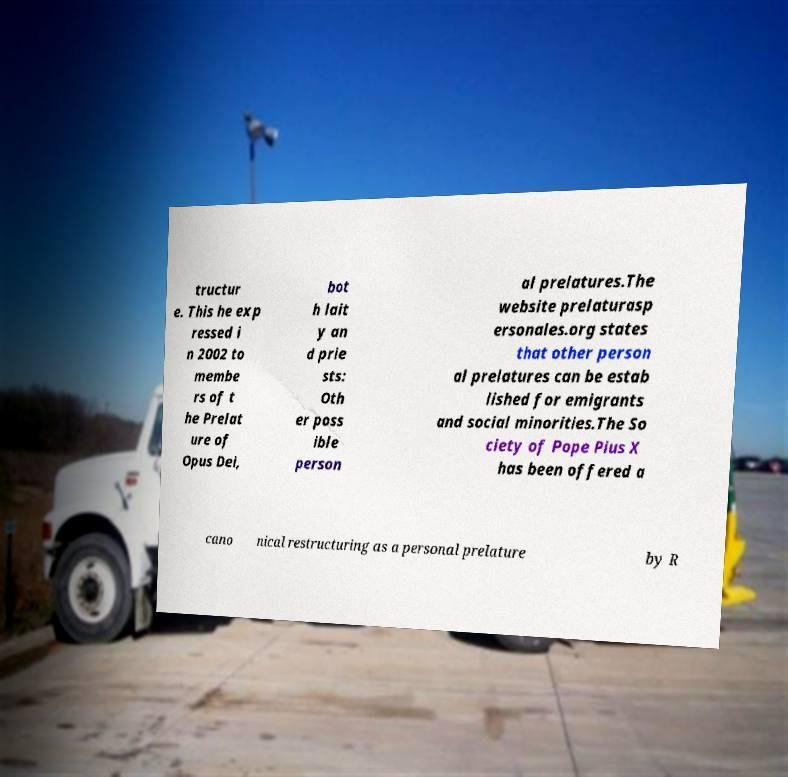Could you extract and type out the text from this image? tructur e. This he exp ressed i n 2002 to membe rs of t he Prelat ure of Opus Dei, bot h lait y an d prie sts: Oth er poss ible person al prelatures.The website prelaturasp ersonales.org states that other person al prelatures can be estab lished for emigrants and social minorities.The So ciety of Pope Pius X has been offered a cano nical restructuring as a personal prelature by R 